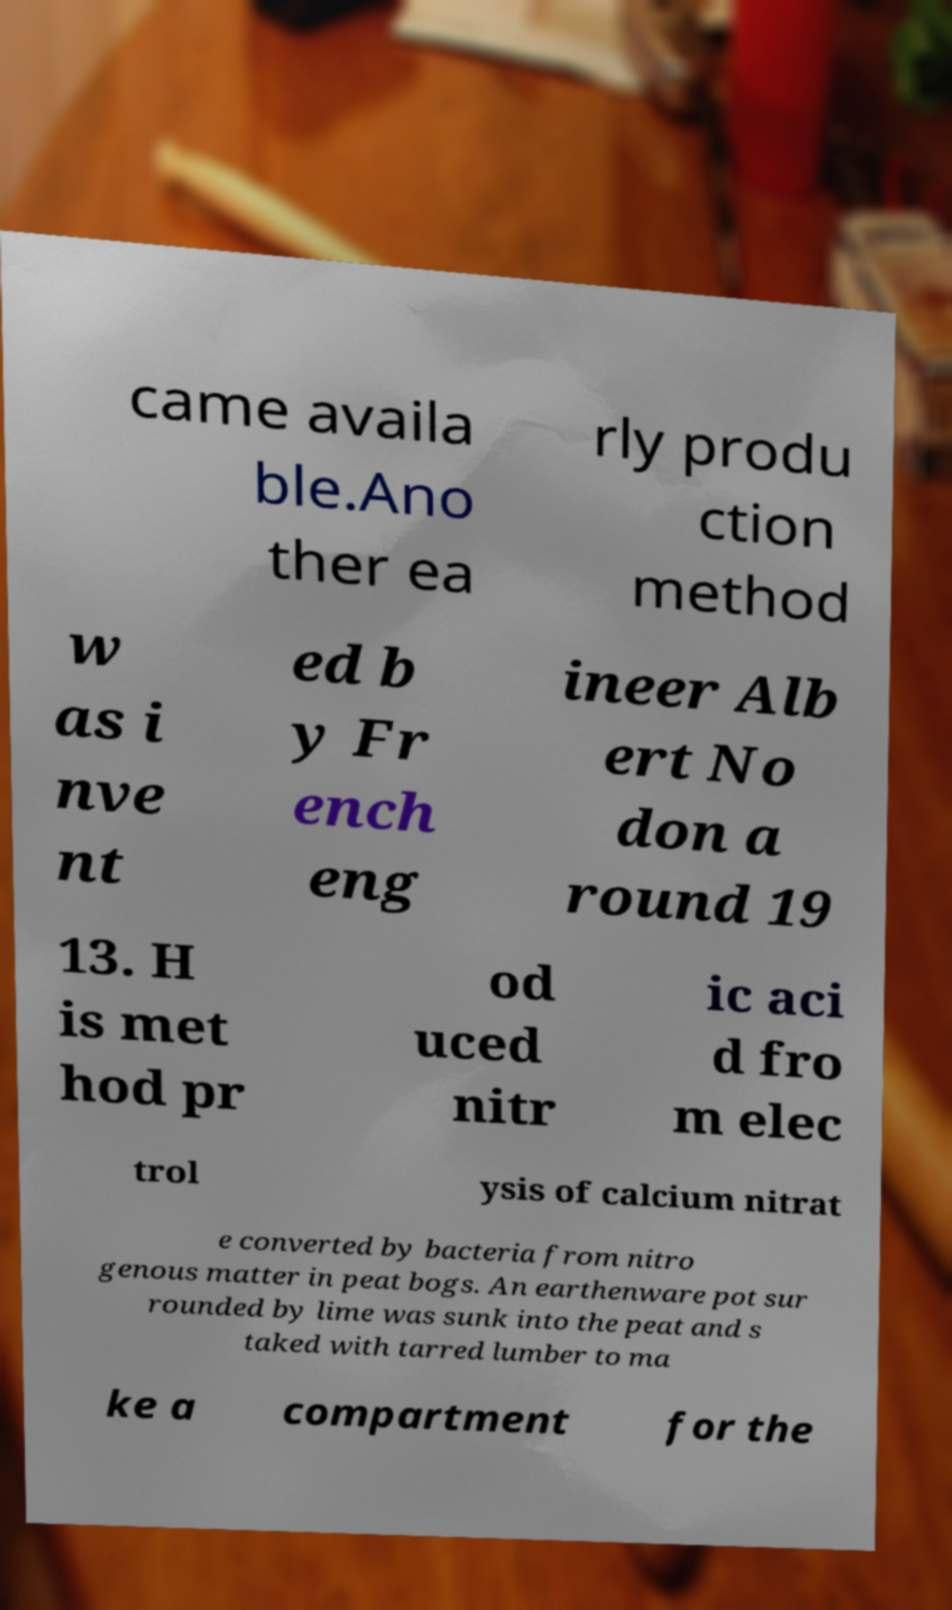I need the written content from this picture converted into text. Can you do that? came availa ble.Ano ther ea rly produ ction method w as i nve nt ed b y Fr ench eng ineer Alb ert No don a round 19 13. H is met hod pr od uced nitr ic aci d fro m elec trol ysis of calcium nitrat e converted by bacteria from nitro genous matter in peat bogs. An earthenware pot sur rounded by lime was sunk into the peat and s taked with tarred lumber to ma ke a compartment for the 